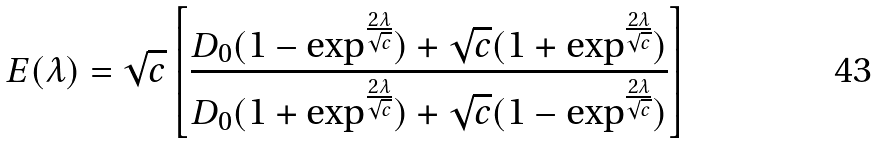Convert formula to latex. <formula><loc_0><loc_0><loc_500><loc_500>E ( \lambda ) = \sqrt { c } \left [ \frac { D _ { 0 } ( 1 - \exp ^ { \frac { 2 \lambda } { \sqrt { c } } } ) + \sqrt { c } ( 1 + \exp ^ { \frac { 2 \lambda } { \sqrt { c } } } ) } { D _ { 0 } ( 1 + \exp ^ { \frac { 2 \lambda } { \sqrt { c } } } ) + \sqrt { c } ( 1 - \exp ^ { \frac { 2 \lambda } { \sqrt { c } } } ) } \right ]</formula> 